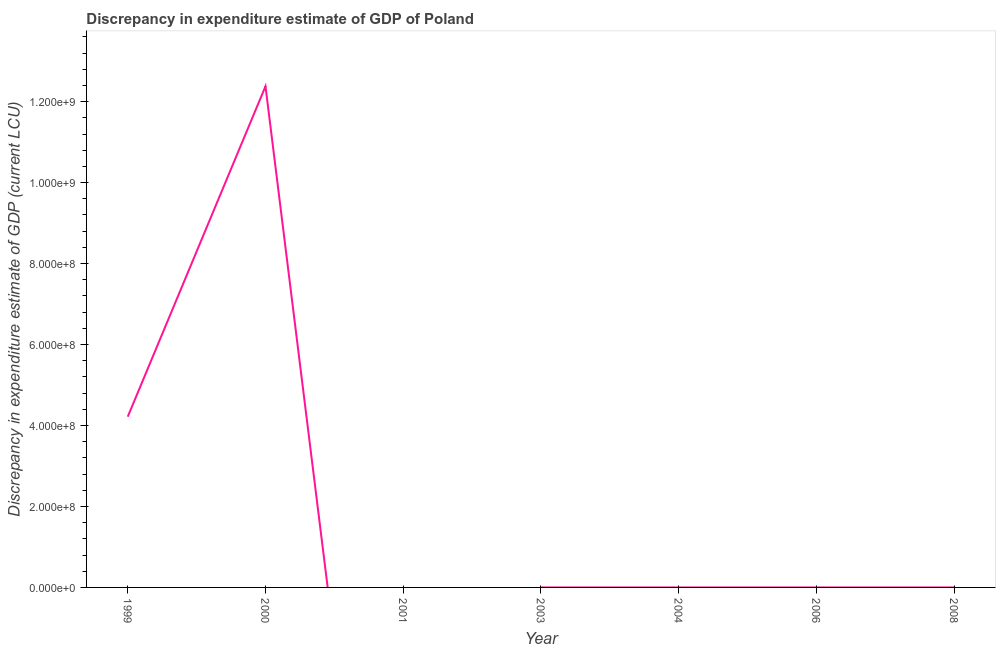What is the discrepancy in expenditure estimate of gdp in 1999?
Offer a terse response. 4.22e+08. Across all years, what is the maximum discrepancy in expenditure estimate of gdp?
Give a very brief answer. 1.24e+09. In which year was the discrepancy in expenditure estimate of gdp maximum?
Provide a succinct answer. 2000. What is the sum of the discrepancy in expenditure estimate of gdp?
Ensure brevity in your answer.  1.66e+09. What is the difference between the discrepancy in expenditure estimate of gdp in 1999 and 2000?
Ensure brevity in your answer.  -8.16e+08. What is the average discrepancy in expenditure estimate of gdp per year?
Provide a short and direct response. 2.37e+08. What is the median discrepancy in expenditure estimate of gdp?
Make the answer very short. 6e-5. Is the difference between the discrepancy in expenditure estimate of gdp in 2003 and 2004 greater than the difference between any two years?
Offer a terse response. No. What is the difference between the highest and the second highest discrepancy in expenditure estimate of gdp?
Your answer should be compact. 8.16e+08. Is the sum of the discrepancy in expenditure estimate of gdp in 1999 and 2003 greater than the maximum discrepancy in expenditure estimate of gdp across all years?
Provide a short and direct response. No. What is the difference between the highest and the lowest discrepancy in expenditure estimate of gdp?
Your answer should be compact. 1.24e+09. In how many years, is the discrepancy in expenditure estimate of gdp greater than the average discrepancy in expenditure estimate of gdp taken over all years?
Your answer should be compact. 2. Does the discrepancy in expenditure estimate of gdp monotonically increase over the years?
Your answer should be compact. No. How many lines are there?
Your answer should be compact. 1. Are the values on the major ticks of Y-axis written in scientific E-notation?
Keep it short and to the point. Yes. Does the graph contain grids?
Provide a short and direct response. No. What is the title of the graph?
Make the answer very short. Discrepancy in expenditure estimate of GDP of Poland. What is the label or title of the X-axis?
Provide a succinct answer. Year. What is the label or title of the Y-axis?
Provide a short and direct response. Discrepancy in expenditure estimate of GDP (current LCU). What is the Discrepancy in expenditure estimate of GDP (current LCU) in 1999?
Your answer should be very brief. 4.22e+08. What is the Discrepancy in expenditure estimate of GDP (current LCU) in 2000?
Your answer should be compact. 1.24e+09. What is the Discrepancy in expenditure estimate of GDP (current LCU) of 2001?
Provide a succinct answer. 0. What is the Discrepancy in expenditure estimate of GDP (current LCU) in 2003?
Provide a short and direct response. 0. What is the Discrepancy in expenditure estimate of GDP (current LCU) of 2004?
Keep it short and to the point. 6e-5. What is the Discrepancy in expenditure estimate of GDP (current LCU) of 2006?
Offer a very short reply. 0. What is the difference between the Discrepancy in expenditure estimate of GDP (current LCU) in 1999 and 2000?
Provide a short and direct response. -8.16e+08. What is the difference between the Discrepancy in expenditure estimate of GDP (current LCU) in 1999 and 2003?
Offer a very short reply. 4.22e+08. What is the difference between the Discrepancy in expenditure estimate of GDP (current LCU) in 1999 and 2004?
Offer a very short reply. 4.22e+08. What is the difference between the Discrepancy in expenditure estimate of GDP (current LCU) in 2000 and 2003?
Make the answer very short. 1.24e+09. What is the difference between the Discrepancy in expenditure estimate of GDP (current LCU) in 2000 and 2004?
Your answer should be compact. 1.24e+09. What is the difference between the Discrepancy in expenditure estimate of GDP (current LCU) in 2003 and 2004?
Your answer should be compact. 6e-5. What is the ratio of the Discrepancy in expenditure estimate of GDP (current LCU) in 1999 to that in 2000?
Offer a very short reply. 0.34. What is the ratio of the Discrepancy in expenditure estimate of GDP (current LCU) in 1999 to that in 2003?
Your answer should be very brief. 3.51e+12. What is the ratio of the Discrepancy in expenditure estimate of GDP (current LCU) in 1999 to that in 2004?
Your answer should be very brief. 7.03e+12. What is the ratio of the Discrepancy in expenditure estimate of GDP (current LCU) in 2000 to that in 2003?
Offer a very short reply. 1.03e+13. What is the ratio of the Discrepancy in expenditure estimate of GDP (current LCU) in 2000 to that in 2004?
Give a very brief answer. 2.06e+13. What is the ratio of the Discrepancy in expenditure estimate of GDP (current LCU) in 2003 to that in 2004?
Ensure brevity in your answer.  2. 